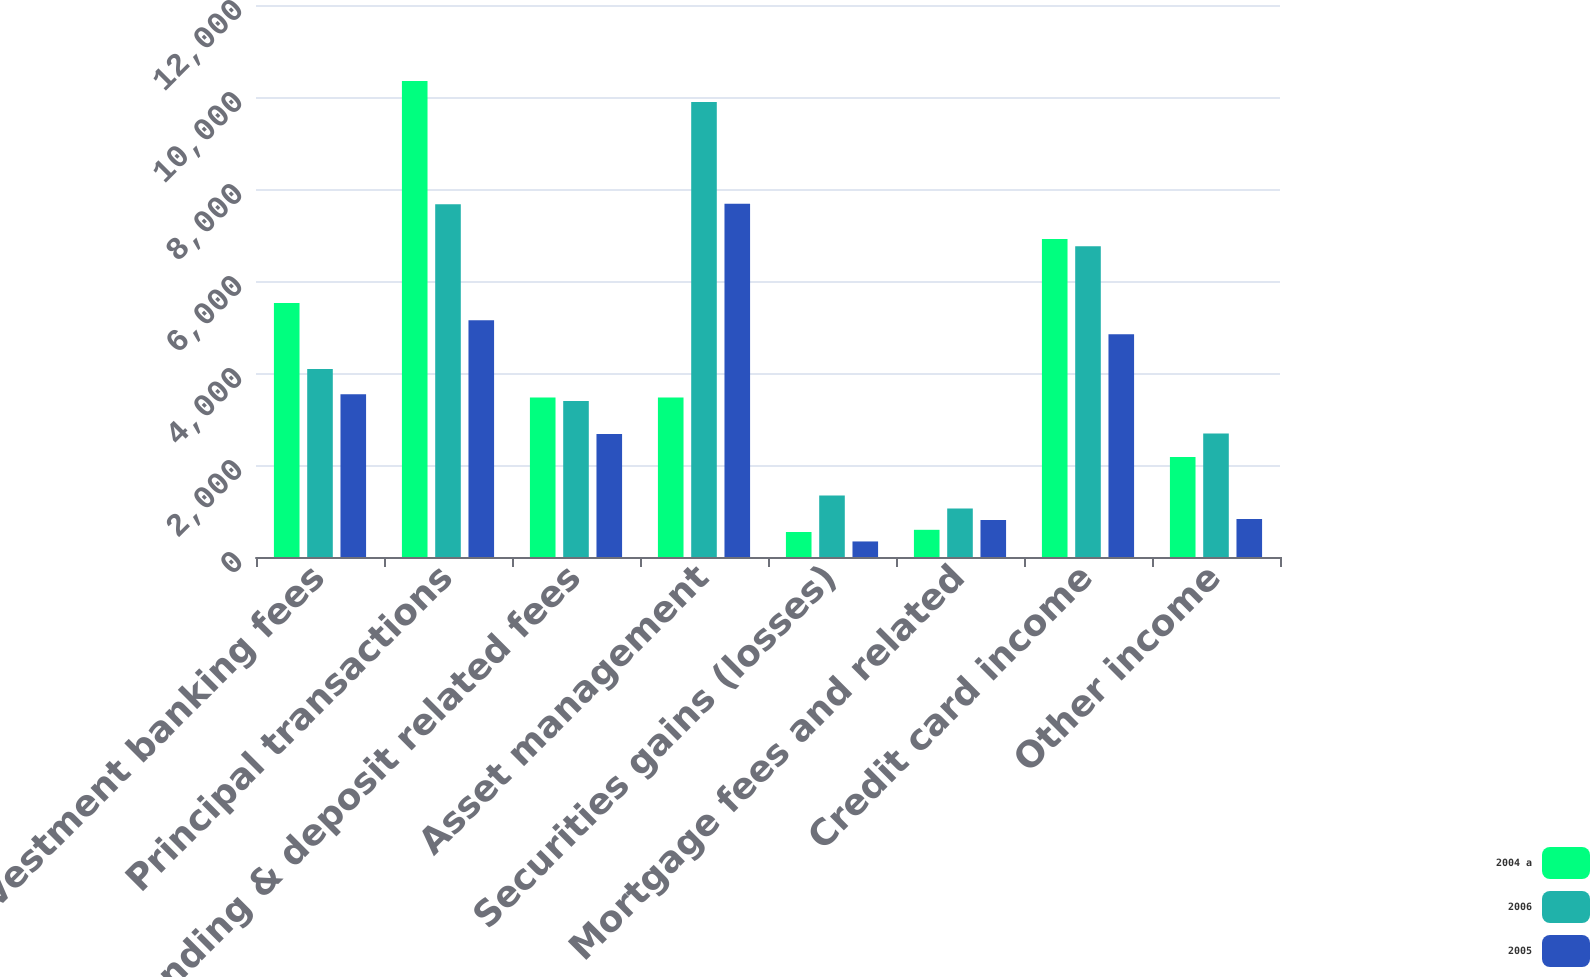Convert chart. <chart><loc_0><loc_0><loc_500><loc_500><stacked_bar_chart><ecel><fcel>Investment banking fees<fcel>Principal transactions<fcel>Lending & deposit related fees<fcel>Asset management<fcel>Securities gains (losses)<fcel>Mortgage fees and related<fcel>Credit card income<fcel>Other income<nl><fcel>2004 a<fcel>5520<fcel>10346<fcel>3468<fcel>3468<fcel>543<fcel>591<fcel>6913<fcel>2175<nl><fcel>2006<fcel>4088<fcel>7669<fcel>3389<fcel>9891<fcel>1336<fcel>1054<fcel>6754<fcel>2684<nl><fcel>2005<fcel>3536<fcel>5148<fcel>2672<fcel>7682<fcel>338<fcel>803<fcel>4840<fcel>826<nl></chart> 